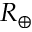Convert formula to latex. <formula><loc_0><loc_0><loc_500><loc_500>R _ { \oplus }</formula> 